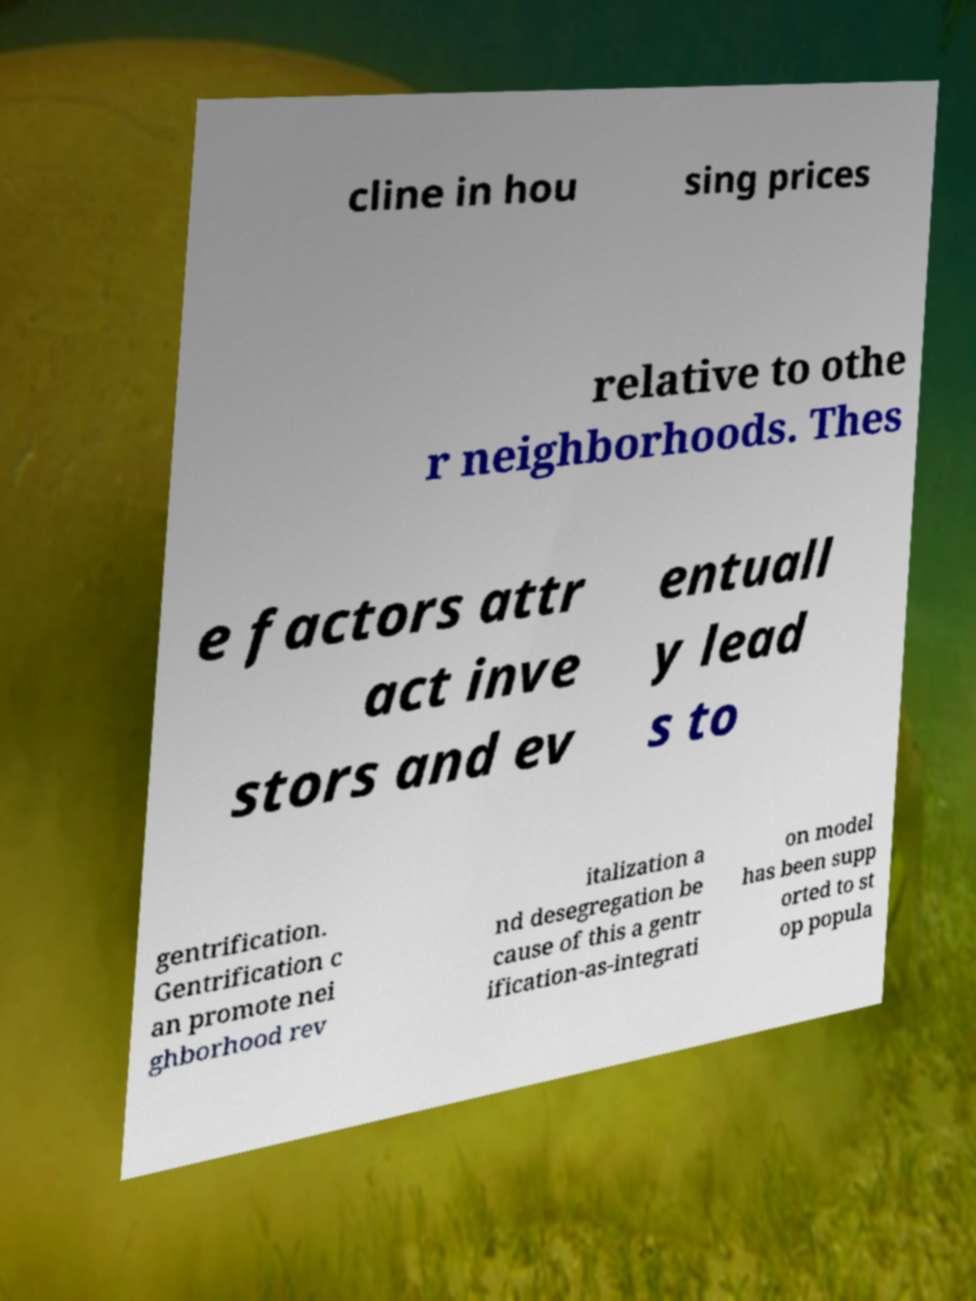Please read and relay the text visible in this image. What does it say? cline in hou sing prices relative to othe r neighborhoods. Thes e factors attr act inve stors and ev entuall y lead s to gentrification. Gentrification c an promote nei ghborhood rev italization a nd desegregation be cause of this a gentr ification-as-integrati on model has been supp orted to st op popula 